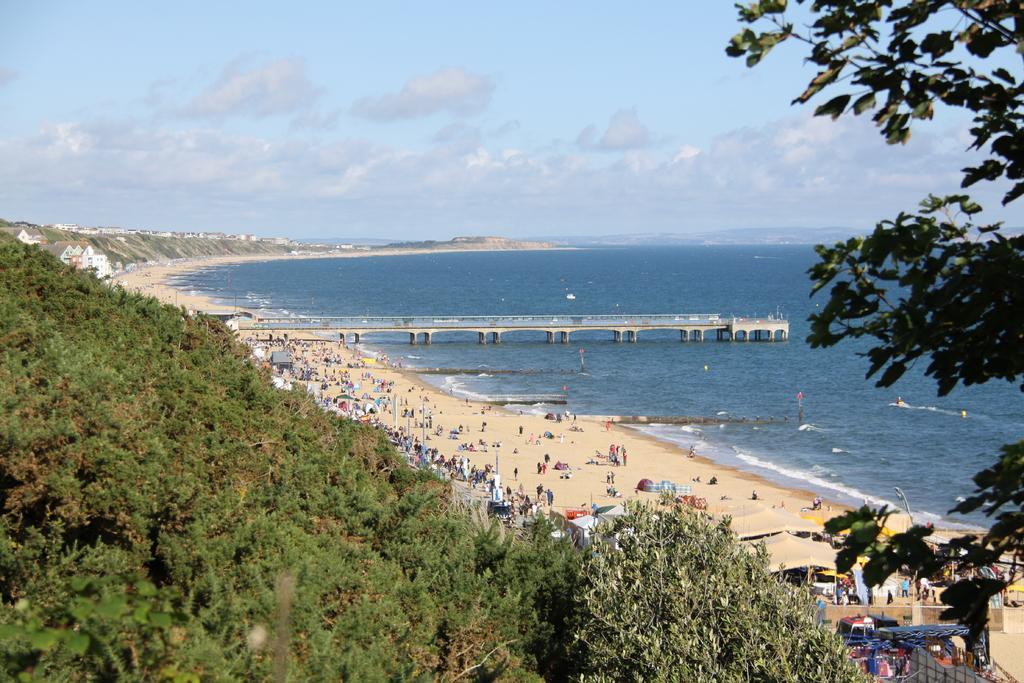In one or two sentences, can you explain what this image depicts? In this image I can see trees, tents, people, bridge, houses, water, cloudy sky, poles and things. 